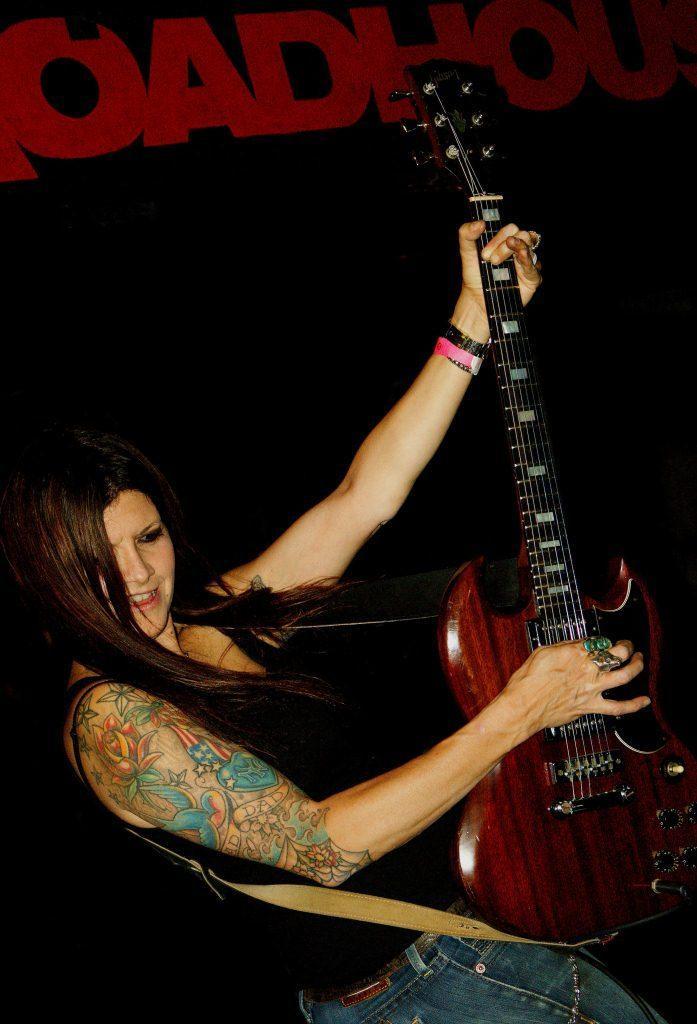Can you describe this image briefly? In this image i can see a woman holding a guitar and playing at the back ground i can see a board. 